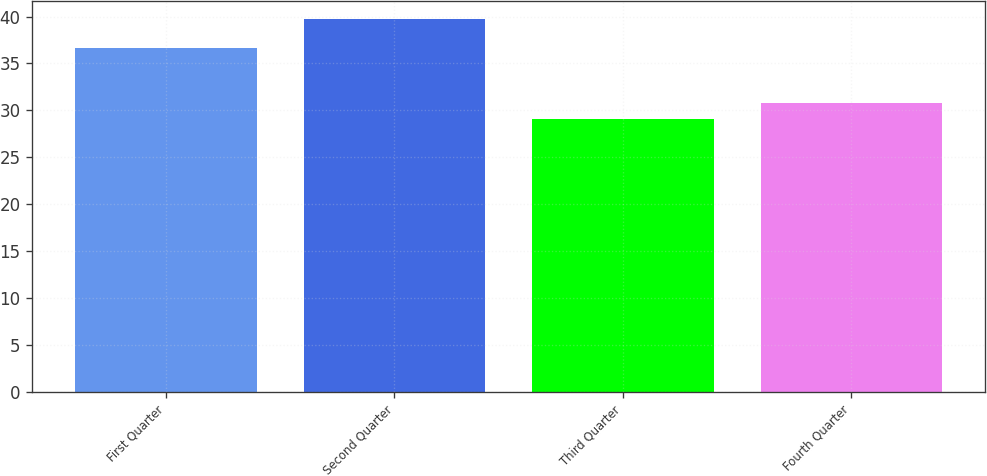Convert chart to OTSL. <chart><loc_0><loc_0><loc_500><loc_500><bar_chart><fcel>First Quarter<fcel>Second Quarter<fcel>Third Quarter<fcel>Fourth Quarter<nl><fcel>36.67<fcel>39.71<fcel>29.12<fcel>30.8<nl></chart> 